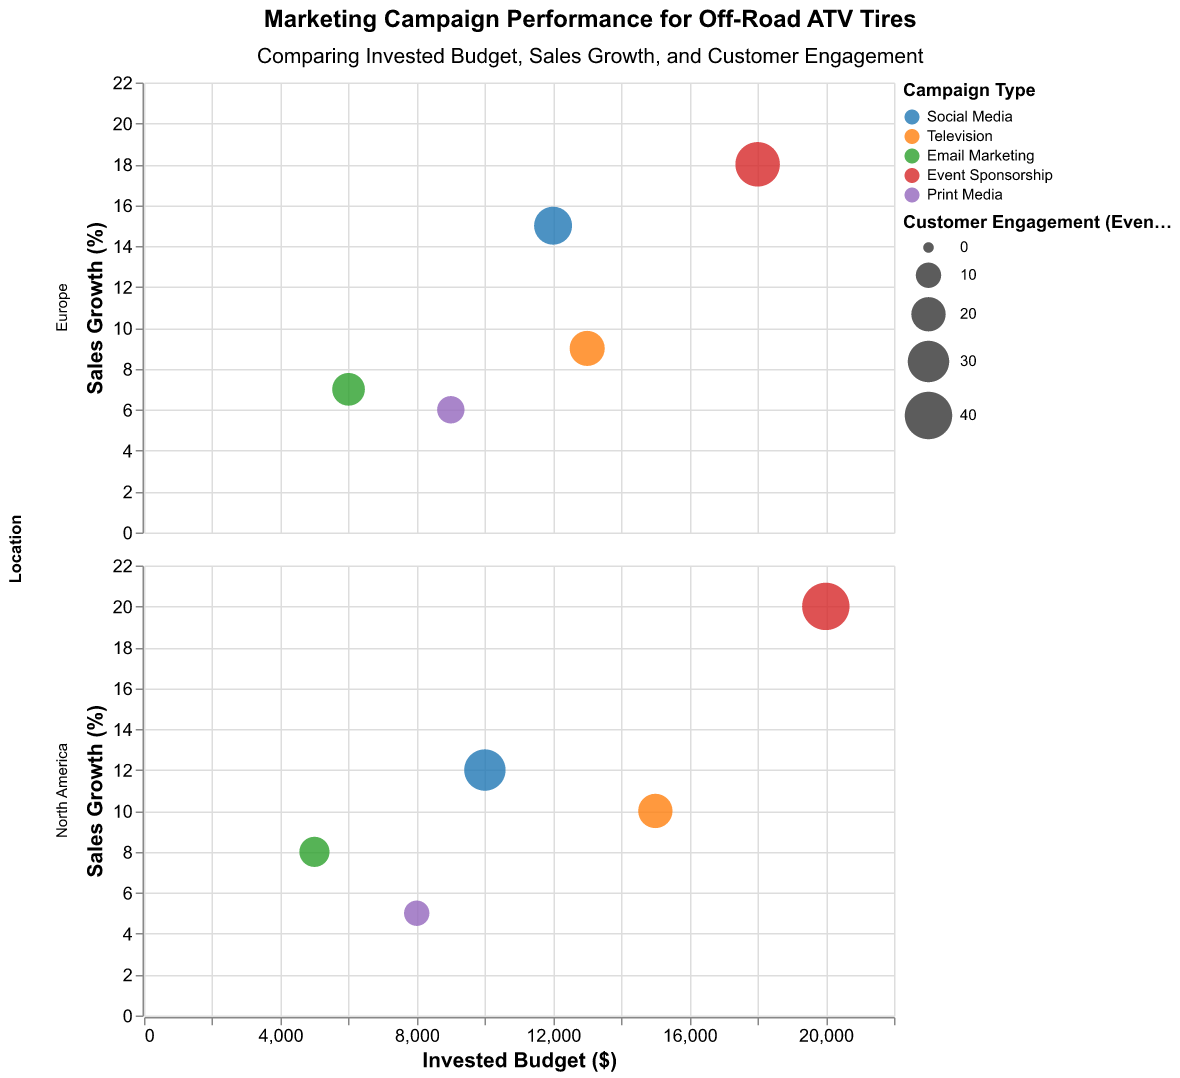What is the title of the figure? The title of the figure is prominently displayed at the top, stating the main subject of the chart.
Answer: Marketing Campaign Performance for Off-Road ATV Tires How many different campaign types are represented in the chart? By looking at the legend, which shows different colors for each campaign type, we can count the number of unique campaign types.
Answer: 5 Which campaign type has the highest sales growth? The campaign type with the data point located at the highest position on the y-axis (Sales Growth) will indicate the highest sales growth. Event Sponsorship has the highest point on this axis.
Answer: Event Sponsorship How does the sales growth compare between Goodyear and Michelin for Event Sponsorship in North America? Locate the data points associated with Event Sponsorship in the North America subplot. Compare the y-values for Goodyear (circle) and Michelin (square).
Answer: Goodyear has 20% and Michelin has 18% What is the customer engagement for Michelin's Email Marketing campaign in Europe? Hover or refer to the tooltip for the data point representing Michelin's Email Marketing in Europe, and note the value for Customer Engagement.
Answer: 18 Which campaign type in the chart received the highest invested budget? Identify the data point furthest to the right on the x-axis (Invested Budget), and check the tooltip or color legend to see the corresponding campaign type.
Answer: Event Sponsorship What is the average sales growth percentage for Print Media campaigns across both locations? Sum the sales growth percentages for Print Media in North America and Europe (5% and 6%), then divide by the number of locations (2).
Answer: 5.5% Are there any campaign types where Goodyear outperformed Michelin in terms of customer engagement? Compare the size of the Goodyear (circle) and Michelin (square) markers within each campaign type using the legend and subplots. Goodyear outperformed Michelin in Event Sponsorship and Print Media.
Answer: Event Sponsorship, Print Media What is the difference in customer engagement between the highest and lowest performing campaign types for Goodyear in North America? Identify the largest and smallest sized circles within the North America subplot for Goodyear. Subtract the value for the smallest from the value for the largest. (40 - 10)
Answer: 30 Which brand and campaign type combination had the lowest sales growth in Europe? Look for the data point with the lowest y-value in the Europe subplot and refer to the tooltip to identify its associated brand and campaign type.
Answer: Michelin, Email Marketing 